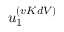Convert formula to latex. <formula><loc_0><loc_0><loc_500><loc_500>u _ { 1 } ^ { ( v K d V ) }</formula> 